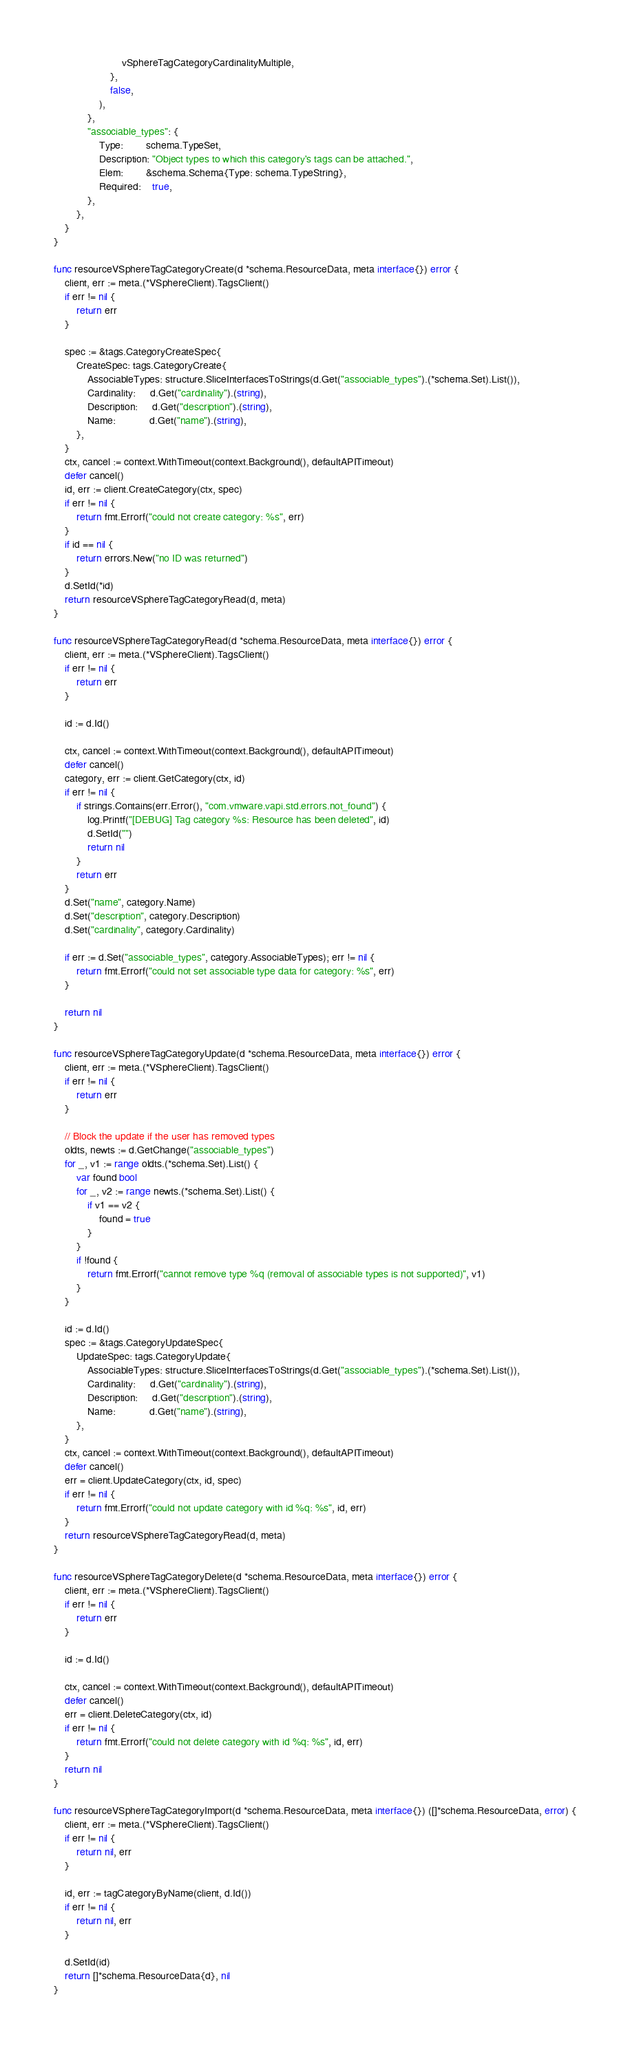<code> <loc_0><loc_0><loc_500><loc_500><_Go_>						vSphereTagCategoryCardinalityMultiple,
					},
					false,
				),
			},
			"associable_types": {
				Type:        schema.TypeSet,
				Description: "Object types to which this category's tags can be attached.",
				Elem:        &schema.Schema{Type: schema.TypeString},
				Required:    true,
			},
		},
	}
}

func resourceVSphereTagCategoryCreate(d *schema.ResourceData, meta interface{}) error {
	client, err := meta.(*VSphereClient).TagsClient()
	if err != nil {
		return err
	}

	spec := &tags.CategoryCreateSpec{
		CreateSpec: tags.CategoryCreate{
			AssociableTypes: structure.SliceInterfacesToStrings(d.Get("associable_types").(*schema.Set).List()),
			Cardinality:     d.Get("cardinality").(string),
			Description:     d.Get("description").(string),
			Name:            d.Get("name").(string),
		},
	}
	ctx, cancel := context.WithTimeout(context.Background(), defaultAPITimeout)
	defer cancel()
	id, err := client.CreateCategory(ctx, spec)
	if err != nil {
		return fmt.Errorf("could not create category: %s", err)
	}
	if id == nil {
		return errors.New("no ID was returned")
	}
	d.SetId(*id)
	return resourceVSphereTagCategoryRead(d, meta)
}

func resourceVSphereTagCategoryRead(d *schema.ResourceData, meta interface{}) error {
	client, err := meta.(*VSphereClient).TagsClient()
	if err != nil {
		return err
	}

	id := d.Id()

	ctx, cancel := context.WithTimeout(context.Background(), defaultAPITimeout)
	defer cancel()
	category, err := client.GetCategory(ctx, id)
	if err != nil {
		if strings.Contains(err.Error(), "com.vmware.vapi.std.errors.not_found") {
			log.Printf("[DEBUG] Tag category %s: Resource has been deleted", id)
			d.SetId("")
			return nil
		}
		return err
	}
	d.Set("name", category.Name)
	d.Set("description", category.Description)
	d.Set("cardinality", category.Cardinality)

	if err := d.Set("associable_types", category.AssociableTypes); err != nil {
		return fmt.Errorf("could not set associable type data for category: %s", err)
	}

	return nil
}

func resourceVSphereTagCategoryUpdate(d *schema.ResourceData, meta interface{}) error {
	client, err := meta.(*VSphereClient).TagsClient()
	if err != nil {
		return err
	}

	// Block the update if the user has removed types
	oldts, newts := d.GetChange("associable_types")
	for _, v1 := range oldts.(*schema.Set).List() {
		var found bool
		for _, v2 := range newts.(*schema.Set).List() {
			if v1 == v2 {
				found = true
			}
		}
		if !found {
			return fmt.Errorf("cannot remove type %q (removal of associable types is not supported)", v1)
		}
	}

	id := d.Id()
	spec := &tags.CategoryUpdateSpec{
		UpdateSpec: tags.CategoryUpdate{
			AssociableTypes: structure.SliceInterfacesToStrings(d.Get("associable_types").(*schema.Set).List()),
			Cardinality:     d.Get("cardinality").(string),
			Description:     d.Get("description").(string),
			Name:            d.Get("name").(string),
		},
	}
	ctx, cancel := context.WithTimeout(context.Background(), defaultAPITimeout)
	defer cancel()
	err = client.UpdateCategory(ctx, id, spec)
	if err != nil {
		return fmt.Errorf("could not update category with id %q: %s", id, err)
	}
	return resourceVSphereTagCategoryRead(d, meta)
}

func resourceVSphereTagCategoryDelete(d *schema.ResourceData, meta interface{}) error {
	client, err := meta.(*VSphereClient).TagsClient()
	if err != nil {
		return err
	}

	id := d.Id()

	ctx, cancel := context.WithTimeout(context.Background(), defaultAPITimeout)
	defer cancel()
	err = client.DeleteCategory(ctx, id)
	if err != nil {
		return fmt.Errorf("could not delete category with id %q: %s", id, err)
	}
	return nil
}

func resourceVSphereTagCategoryImport(d *schema.ResourceData, meta interface{}) ([]*schema.ResourceData, error) {
	client, err := meta.(*VSphereClient).TagsClient()
	if err != nil {
		return nil, err
	}

	id, err := tagCategoryByName(client, d.Id())
	if err != nil {
		return nil, err
	}

	d.SetId(id)
	return []*schema.ResourceData{d}, nil
}
</code> 